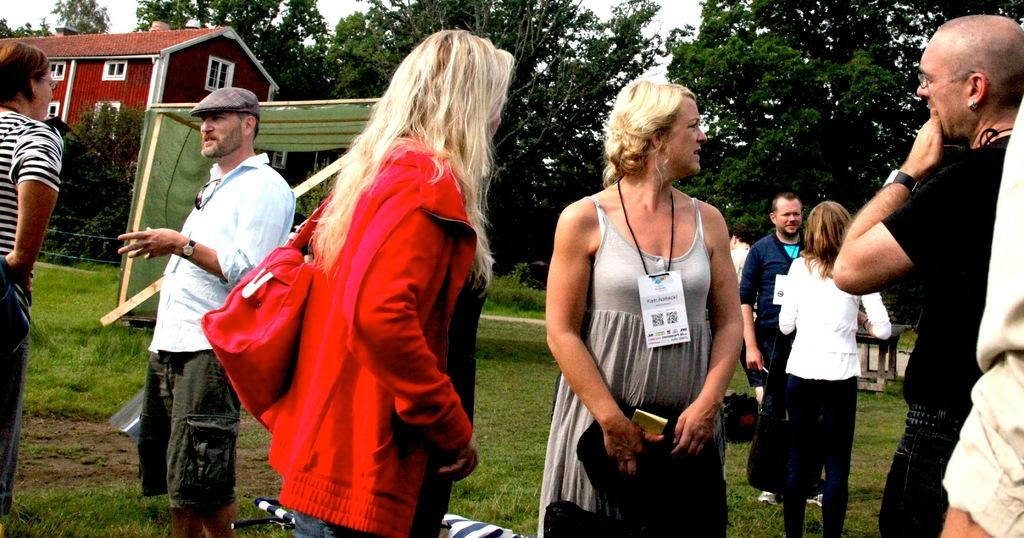How many people are in the image? There is a group of persons in the image, but the exact number cannot be determined from the provided facts. What is located behind the persons in the image? There is a shed and a building behind the persons in the image. What type of vegetation is visible in the image? Grass is visible in the image. What type of furniture is present in the image? There is a table in the image. What type of natural feature is visible in the image? There is a group of trees in the image. What is visible at the top of the image? The sky is visible at the top of the image. What type of haircut is the person in the image attempting to give themselves? There is no person in the image attempting to give themselves a haircut. What type of quilt is draped over the table in the image? There is no quilt present in the image. 